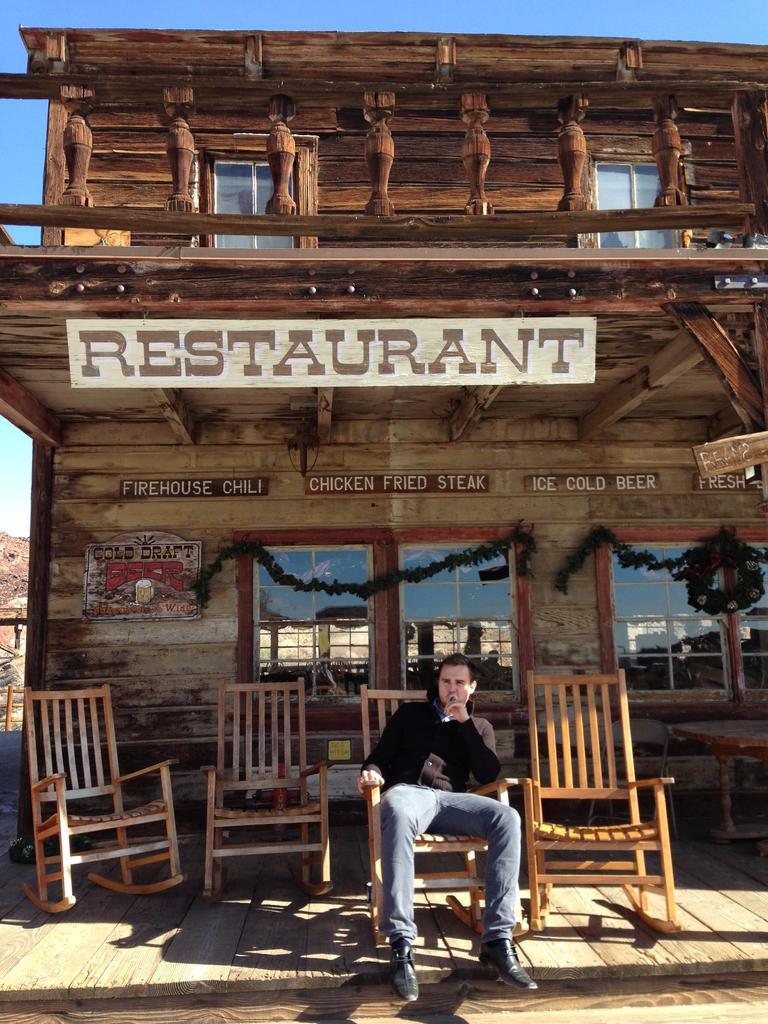Please provide a concise description of this image. In the middle bottom of the image, there is a person sitting on the chair, wearing full sleeve black color shirt and grey color jeans, in front of the restaurant made up of wood. In the top, there is a sky blue in color. In the middle background, a window is visible. In the left bottom, mountains are visible. It looks as if the image is taken during time. 